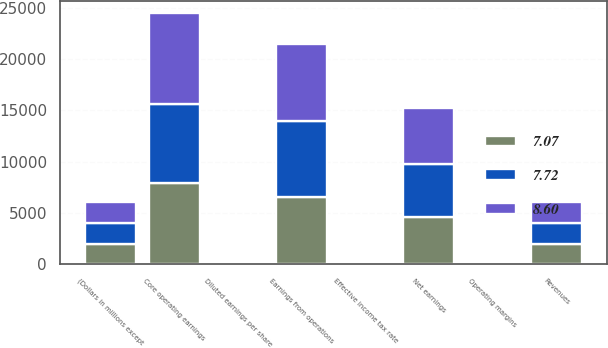Convert chart. <chart><loc_0><loc_0><loc_500><loc_500><stacked_bar_chart><ecel><fcel>(Dollars in millions except<fcel>Revenues<fcel>Earnings from operations<fcel>Operating margins<fcel>Effective income tax rate<fcel>Net earnings<fcel>Diluted earnings per share<fcel>Core operating earnings<nl><fcel>7.72<fcel>2015<fcel>2014<fcel>7443<fcel>7.7<fcel>27.7<fcel>5176<fcel>7.44<fcel>7741<nl><fcel>8.6<fcel>2014<fcel>2014<fcel>7473<fcel>8.2<fcel>23.7<fcel>5446<fcel>7.38<fcel>8860<nl><fcel>7.07<fcel>2013<fcel>2014<fcel>6562<fcel>7.6<fcel>26.4<fcel>4585<fcel>5.96<fcel>7876<nl></chart> 